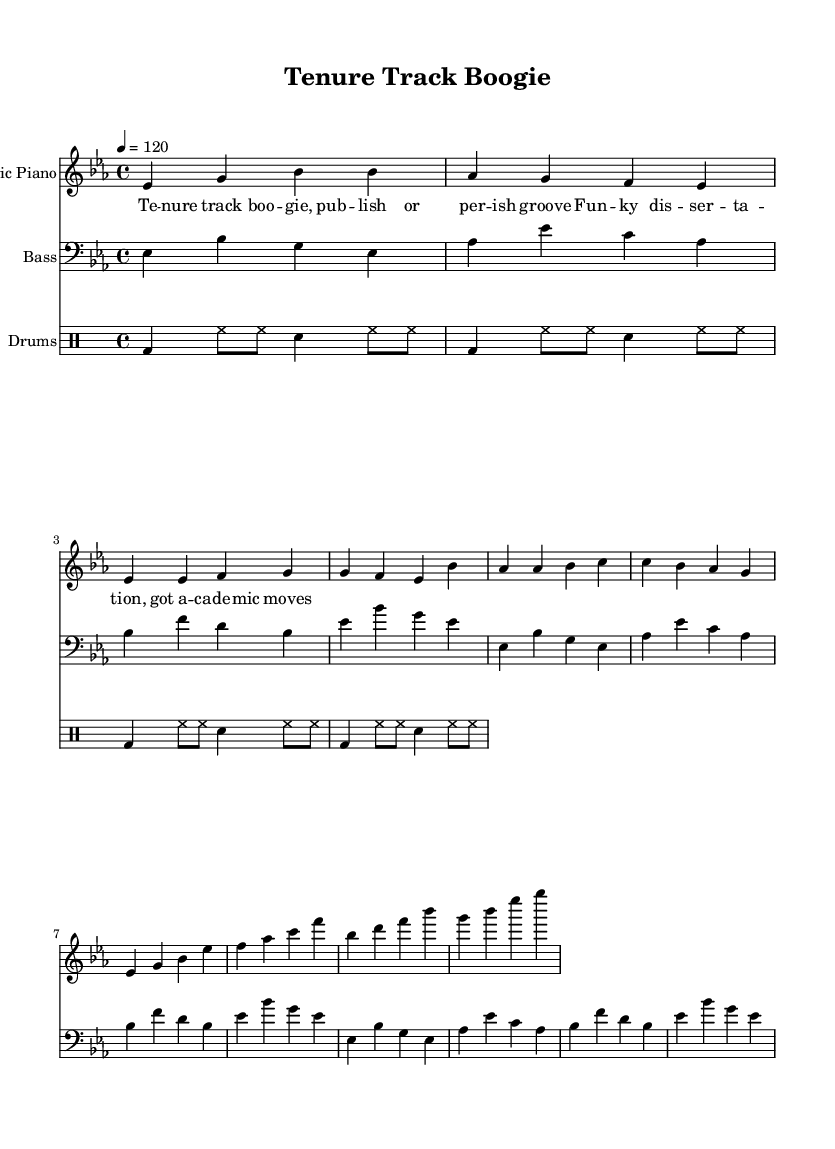What is the key signature of this music? The key signature is indicated by the sharp or flat symbols at the beginning of the staff. Here, there is a B flat, E flat, and A flat noted, which identifies the piece as being in E flat major.
Answer: E flat major What is the time signature of the piece? The time signature is shown at the beginning of the staff and is written as a fraction. Here, it is 4 over 4, which means there are four beats in a measure, and each quarter note counts as one beat.
Answer: 4/4 What is the tempo marking of this music? The tempo marking is specified in the score, typically in beats per minute. In this case, it is indicated as "4 = 120," meaning there are 120 quarter-note beats per minute.
Answer: 120 How many measures are in the chorus section? To find the number of measures in the chorus section, we count the measures represented in that part of the sheet music. The chorus consists of 4 measures.
Answer: 4 What instruments are included in this arrangement? The piece lists types of staves to indicate the instruments used, which are in the score's section header. The instruments shown are Electric Piano, Bass, and Drums.
Answer: Electric Piano, Bass, Drums What is the lyrical theme of the song? By analyzing the lyrics provided, which refer to academic life, the theme revolves around the experiences and movements within an academic setting, particularly focusing on the tenure track process and the energy of a disco tune.
Answer: Academic life Is there a repeated bass line in this music? The bass line is repeated multiple times throughout the piece, as indicated by the "repeat unfold" direction in the music notation, confirming the bass line pattern is repeated for both the intro, verse, and chorus sections.
Answer: Yes 